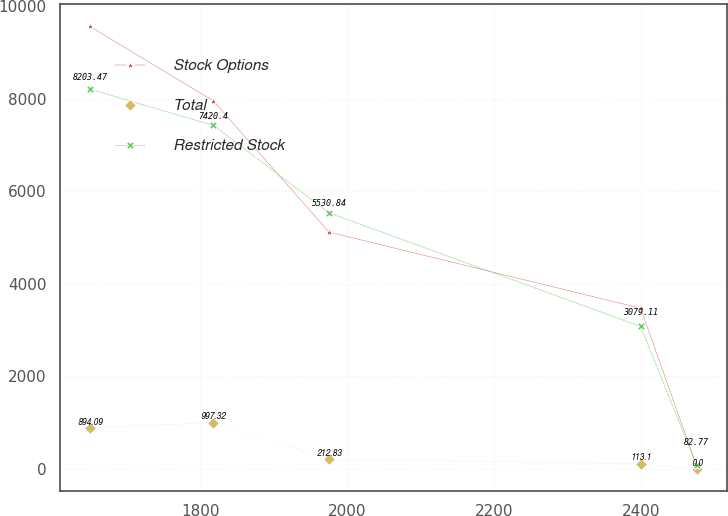Convert chart. <chart><loc_0><loc_0><loc_500><loc_500><line_chart><ecel><fcel>Stock Options<fcel>Total<fcel>Restricted Stock<nl><fcel>1649.65<fcel>9556.75<fcel>894.09<fcel>8203.47<nl><fcel>1817.66<fcel>7950.91<fcel>997.32<fcel>7420.4<nl><fcel>1975.31<fcel>5116.3<fcel>212.83<fcel>5530.84<nl><fcel>2399.89<fcel>3472.29<fcel>113.1<fcel>3079.11<nl><fcel>2476.18<fcel>68.2<fcel>0<fcel>82.77<nl></chart> 